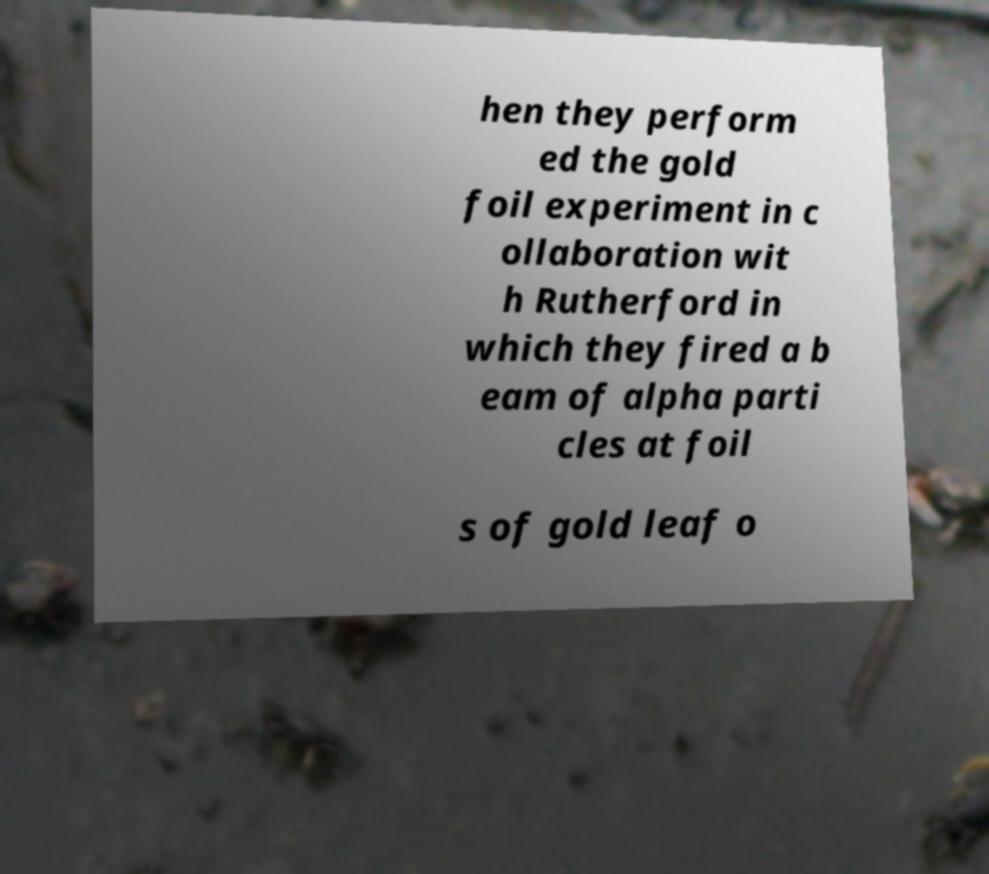Could you extract and type out the text from this image? hen they perform ed the gold foil experiment in c ollaboration wit h Rutherford in which they fired a b eam of alpha parti cles at foil s of gold leaf o 